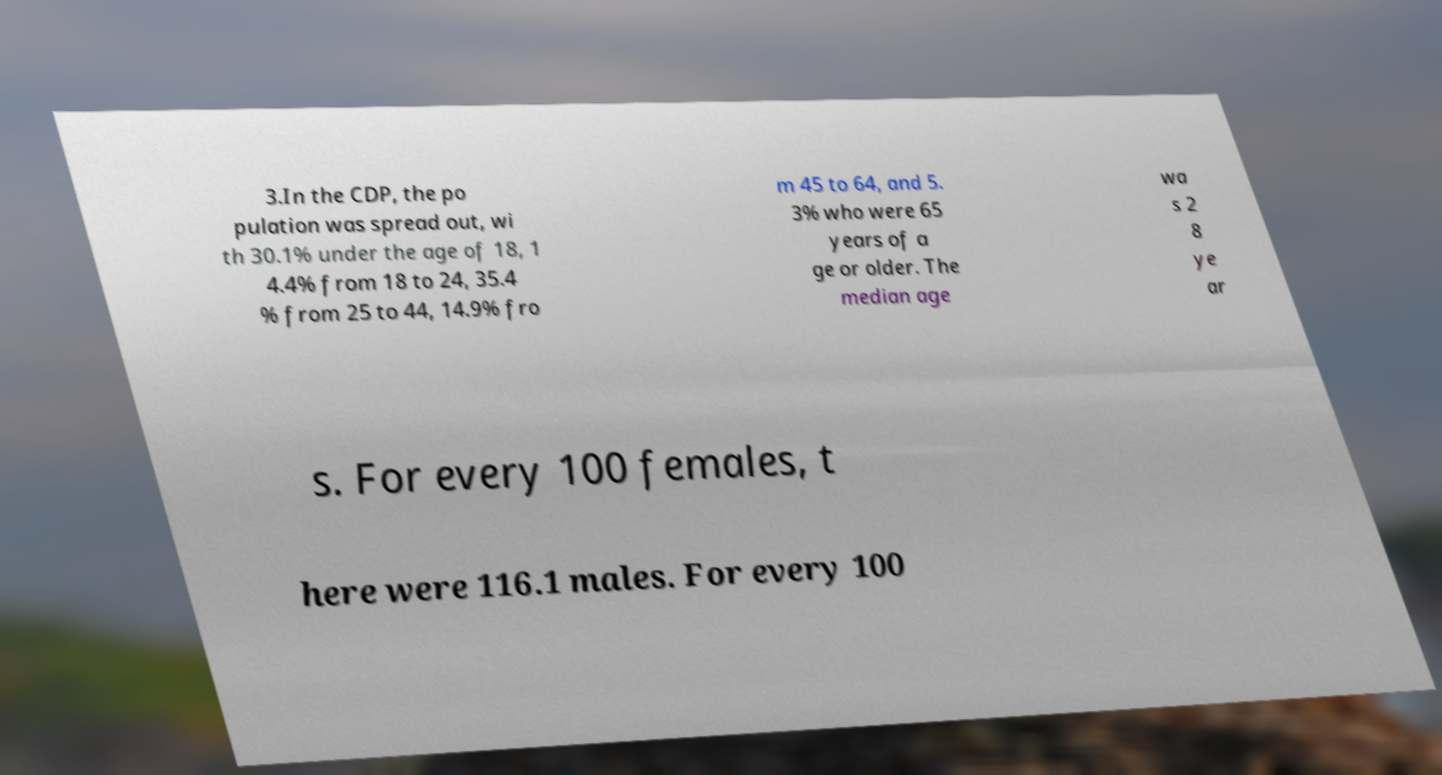Could you extract and type out the text from this image? 3.In the CDP, the po pulation was spread out, wi th 30.1% under the age of 18, 1 4.4% from 18 to 24, 35.4 % from 25 to 44, 14.9% fro m 45 to 64, and 5. 3% who were 65 years of a ge or older. The median age wa s 2 8 ye ar s. For every 100 females, t here were 116.1 males. For every 100 